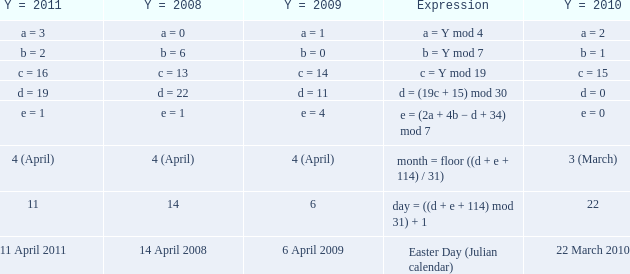What is the y = 2008 when the expression is easter day (julian calendar)? 14 April 2008. Could you parse the entire table? {'header': ['Y = 2011', 'Y = 2008', 'Y = 2009', 'Expression', 'Y = 2010'], 'rows': [['a = 3', 'a = 0', 'a = 1', 'a = Y mod 4', 'a = 2'], ['b = 2', 'b = 6', 'b = 0', 'b = Y mod 7', 'b = 1'], ['c = 16', 'c = 13', 'c = 14', 'c = Y mod 19', 'c = 15'], ['d = 19', 'd = 22', 'd = 11', 'd = (19c + 15) mod 30', 'd = 0'], ['e = 1', 'e = 1', 'e = 4', 'e = (2a + 4b − d + 34) mod 7', 'e = 0'], ['4 (April)', '4 (April)', '4 (April)', 'month = floor ((d + e + 114) / 31)', '3 (March)'], ['11', '14', '6', 'day = ((d + e + 114) mod 31) + 1', '22'], ['11 April 2011', '14 April 2008', '6 April 2009', 'Easter Day (Julian calendar)', '22 March 2010']]} 